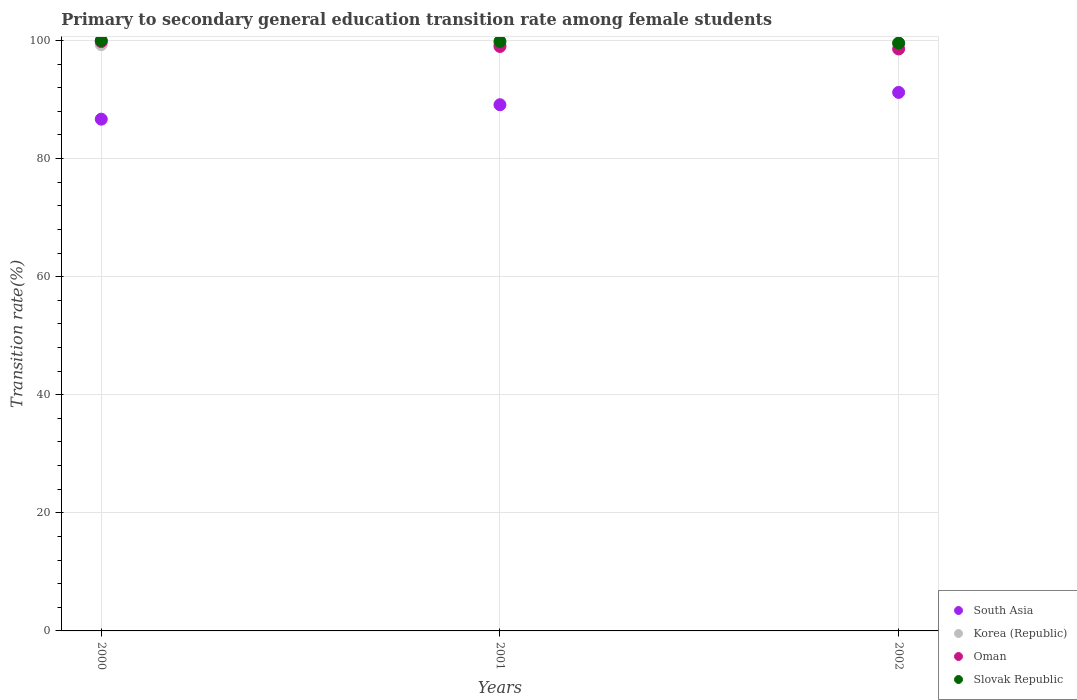How many different coloured dotlines are there?
Ensure brevity in your answer.  4. What is the transition rate in Slovak Republic in 2001?
Your answer should be compact. 99.84. Across all years, what is the maximum transition rate in Slovak Republic?
Your answer should be very brief. 100. Across all years, what is the minimum transition rate in Korea (Republic)?
Offer a very short reply. 99.28. In which year was the transition rate in South Asia maximum?
Provide a succinct answer. 2002. What is the total transition rate in Oman in the graph?
Give a very brief answer. 297.37. What is the difference between the transition rate in Korea (Republic) in 2000 and that in 2002?
Provide a short and direct response. -0.15. What is the difference between the transition rate in Korea (Republic) in 2001 and the transition rate in Slovak Republic in 2000?
Offer a very short reply. -0.72. What is the average transition rate in South Asia per year?
Offer a very short reply. 89. In the year 2000, what is the difference between the transition rate in Oman and transition rate in South Asia?
Your answer should be very brief. 13.14. What is the ratio of the transition rate in Oman in 2000 to that in 2002?
Offer a terse response. 1.01. What is the difference between the highest and the second highest transition rate in Korea (Republic)?
Provide a short and direct response. 0.15. What is the difference between the highest and the lowest transition rate in South Asia?
Keep it short and to the point. 4.53. In how many years, is the transition rate in Oman greater than the average transition rate in Oman taken over all years?
Offer a very short reply. 1. Is the transition rate in Slovak Republic strictly greater than the transition rate in South Asia over the years?
Give a very brief answer. Yes. Are the values on the major ticks of Y-axis written in scientific E-notation?
Give a very brief answer. No. Does the graph contain grids?
Your response must be concise. Yes. Where does the legend appear in the graph?
Make the answer very short. Bottom right. What is the title of the graph?
Your answer should be compact. Primary to secondary general education transition rate among female students. What is the label or title of the X-axis?
Your answer should be compact. Years. What is the label or title of the Y-axis?
Offer a very short reply. Transition rate(%). What is the Transition rate(%) of South Asia in 2000?
Provide a short and direct response. 86.68. What is the Transition rate(%) of Korea (Republic) in 2000?
Make the answer very short. 99.31. What is the Transition rate(%) of Oman in 2000?
Ensure brevity in your answer.  99.81. What is the Transition rate(%) in Slovak Republic in 2000?
Offer a very short reply. 100. What is the Transition rate(%) in South Asia in 2001?
Offer a very short reply. 89.12. What is the Transition rate(%) in Korea (Republic) in 2001?
Provide a short and direct response. 99.28. What is the Transition rate(%) of Oman in 2001?
Your answer should be very brief. 98.99. What is the Transition rate(%) in Slovak Republic in 2001?
Make the answer very short. 99.84. What is the Transition rate(%) in South Asia in 2002?
Offer a very short reply. 91.21. What is the Transition rate(%) in Korea (Republic) in 2002?
Give a very brief answer. 99.46. What is the Transition rate(%) in Oman in 2002?
Make the answer very short. 98.57. What is the Transition rate(%) of Slovak Republic in 2002?
Provide a succinct answer. 99.56. Across all years, what is the maximum Transition rate(%) of South Asia?
Your answer should be compact. 91.21. Across all years, what is the maximum Transition rate(%) of Korea (Republic)?
Offer a very short reply. 99.46. Across all years, what is the maximum Transition rate(%) of Oman?
Give a very brief answer. 99.81. Across all years, what is the minimum Transition rate(%) in South Asia?
Ensure brevity in your answer.  86.68. Across all years, what is the minimum Transition rate(%) of Korea (Republic)?
Provide a short and direct response. 99.28. Across all years, what is the minimum Transition rate(%) in Oman?
Offer a terse response. 98.57. Across all years, what is the minimum Transition rate(%) of Slovak Republic?
Keep it short and to the point. 99.56. What is the total Transition rate(%) in South Asia in the graph?
Give a very brief answer. 267.01. What is the total Transition rate(%) in Korea (Republic) in the graph?
Ensure brevity in your answer.  298.05. What is the total Transition rate(%) of Oman in the graph?
Your answer should be compact. 297.37. What is the total Transition rate(%) in Slovak Republic in the graph?
Your answer should be very brief. 299.41. What is the difference between the Transition rate(%) of South Asia in 2000 and that in 2001?
Give a very brief answer. -2.44. What is the difference between the Transition rate(%) of Korea (Republic) in 2000 and that in 2001?
Provide a succinct answer. 0.03. What is the difference between the Transition rate(%) of Oman in 2000 and that in 2001?
Offer a terse response. 0.82. What is the difference between the Transition rate(%) in Slovak Republic in 2000 and that in 2001?
Make the answer very short. 0.16. What is the difference between the Transition rate(%) of South Asia in 2000 and that in 2002?
Provide a succinct answer. -4.53. What is the difference between the Transition rate(%) of Korea (Republic) in 2000 and that in 2002?
Your answer should be very brief. -0.15. What is the difference between the Transition rate(%) of Oman in 2000 and that in 2002?
Your answer should be compact. 1.25. What is the difference between the Transition rate(%) of Slovak Republic in 2000 and that in 2002?
Your response must be concise. 0.44. What is the difference between the Transition rate(%) in South Asia in 2001 and that in 2002?
Your answer should be very brief. -2.09. What is the difference between the Transition rate(%) in Korea (Republic) in 2001 and that in 2002?
Offer a very short reply. -0.17. What is the difference between the Transition rate(%) of Oman in 2001 and that in 2002?
Provide a succinct answer. 0.42. What is the difference between the Transition rate(%) in Slovak Republic in 2001 and that in 2002?
Provide a short and direct response. 0.28. What is the difference between the Transition rate(%) in South Asia in 2000 and the Transition rate(%) in Korea (Republic) in 2001?
Offer a very short reply. -12.61. What is the difference between the Transition rate(%) of South Asia in 2000 and the Transition rate(%) of Oman in 2001?
Provide a short and direct response. -12.31. What is the difference between the Transition rate(%) in South Asia in 2000 and the Transition rate(%) in Slovak Republic in 2001?
Give a very brief answer. -13.17. What is the difference between the Transition rate(%) in Korea (Republic) in 2000 and the Transition rate(%) in Oman in 2001?
Provide a short and direct response. 0.32. What is the difference between the Transition rate(%) in Korea (Republic) in 2000 and the Transition rate(%) in Slovak Republic in 2001?
Offer a terse response. -0.54. What is the difference between the Transition rate(%) in Oman in 2000 and the Transition rate(%) in Slovak Republic in 2001?
Your answer should be compact. -0.03. What is the difference between the Transition rate(%) in South Asia in 2000 and the Transition rate(%) in Korea (Republic) in 2002?
Offer a terse response. -12.78. What is the difference between the Transition rate(%) in South Asia in 2000 and the Transition rate(%) in Oman in 2002?
Provide a succinct answer. -11.89. What is the difference between the Transition rate(%) in South Asia in 2000 and the Transition rate(%) in Slovak Republic in 2002?
Give a very brief answer. -12.89. What is the difference between the Transition rate(%) of Korea (Republic) in 2000 and the Transition rate(%) of Oman in 2002?
Keep it short and to the point. 0.74. What is the difference between the Transition rate(%) in Korea (Republic) in 2000 and the Transition rate(%) in Slovak Republic in 2002?
Ensure brevity in your answer.  -0.25. What is the difference between the Transition rate(%) of Oman in 2000 and the Transition rate(%) of Slovak Republic in 2002?
Your answer should be compact. 0.25. What is the difference between the Transition rate(%) in South Asia in 2001 and the Transition rate(%) in Korea (Republic) in 2002?
Provide a succinct answer. -10.34. What is the difference between the Transition rate(%) of South Asia in 2001 and the Transition rate(%) of Oman in 2002?
Ensure brevity in your answer.  -9.45. What is the difference between the Transition rate(%) of South Asia in 2001 and the Transition rate(%) of Slovak Republic in 2002?
Make the answer very short. -10.44. What is the difference between the Transition rate(%) in Korea (Republic) in 2001 and the Transition rate(%) in Oman in 2002?
Offer a terse response. 0.72. What is the difference between the Transition rate(%) of Korea (Republic) in 2001 and the Transition rate(%) of Slovak Republic in 2002?
Provide a succinct answer. -0.28. What is the difference between the Transition rate(%) in Oman in 2001 and the Transition rate(%) in Slovak Republic in 2002?
Give a very brief answer. -0.57. What is the average Transition rate(%) in South Asia per year?
Keep it short and to the point. 89. What is the average Transition rate(%) of Korea (Republic) per year?
Keep it short and to the point. 99.35. What is the average Transition rate(%) of Oman per year?
Offer a very short reply. 99.12. What is the average Transition rate(%) of Slovak Republic per year?
Keep it short and to the point. 99.8. In the year 2000, what is the difference between the Transition rate(%) of South Asia and Transition rate(%) of Korea (Republic)?
Your answer should be very brief. -12.63. In the year 2000, what is the difference between the Transition rate(%) in South Asia and Transition rate(%) in Oman?
Make the answer very short. -13.14. In the year 2000, what is the difference between the Transition rate(%) in South Asia and Transition rate(%) in Slovak Republic?
Provide a succinct answer. -13.32. In the year 2000, what is the difference between the Transition rate(%) in Korea (Republic) and Transition rate(%) in Oman?
Make the answer very short. -0.5. In the year 2000, what is the difference between the Transition rate(%) of Korea (Republic) and Transition rate(%) of Slovak Republic?
Make the answer very short. -0.69. In the year 2000, what is the difference between the Transition rate(%) of Oman and Transition rate(%) of Slovak Republic?
Your answer should be very brief. -0.19. In the year 2001, what is the difference between the Transition rate(%) of South Asia and Transition rate(%) of Korea (Republic)?
Keep it short and to the point. -10.16. In the year 2001, what is the difference between the Transition rate(%) of South Asia and Transition rate(%) of Oman?
Keep it short and to the point. -9.87. In the year 2001, what is the difference between the Transition rate(%) in South Asia and Transition rate(%) in Slovak Republic?
Your answer should be compact. -10.72. In the year 2001, what is the difference between the Transition rate(%) of Korea (Republic) and Transition rate(%) of Oman?
Your answer should be very brief. 0.29. In the year 2001, what is the difference between the Transition rate(%) in Korea (Republic) and Transition rate(%) in Slovak Republic?
Offer a very short reply. -0.56. In the year 2001, what is the difference between the Transition rate(%) of Oman and Transition rate(%) of Slovak Republic?
Provide a short and direct response. -0.85. In the year 2002, what is the difference between the Transition rate(%) in South Asia and Transition rate(%) in Korea (Republic)?
Make the answer very short. -8.25. In the year 2002, what is the difference between the Transition rate(%) of South Asia and Transition rate(%) of Oman?
Keep it short and to the point. -7.36. In the year 2002, what is the difference between the Transition rate(%) of South Asia and Transition rate(%) of Slovak Republic?
Make the answer very short. -8.35. In the year 2002, what is the difference between the Transition rate(%) in Korea (Republic) and Transition rate(%) in Oman?
Your response must be concise. 0.89. In the year 2002, what is the difference between the Transition rate(%) in Korea (Republic) and Transition rate(%) in Slovak Republic?
Provide a short and direct response. -0.11. In the year 2002, what is the difference between the Transition rate(%) of Oman and Transition rate(%) of Slovak Republic?
Your answer should be very brief. -1. What is the ratio of the Transition rate(%) of South Asia in 2000 to that in 2001?
Make the answer very short. 0.97. What is the ratio of the Transition rate(%) of Korea (Republic) in 2000 to that in 2001?
Make the answer very short. 1. What is the ratio of the Transition rate(%) in Oman in 2000 to that in 2001?
Make the answer very short. 1.01. What is the ratio of the Transition rate(%) of South Asia in 2000 to that in 2002?
Offer a very short reply. 0.95. What is the ratio of the Transition rate(%) in Oman in 2000 to that in 2002?
Provide a succinct answer. 1.01. What is the ratio of the Transition rate(%) in Slovak Republic in 2000 to that in 2002?
Offer a very short reply. 1. What is the ratio of the Transition rate(%) in South Asia in 2001 to that in 2002?
Provide a succinct answer. 0.98. What is the ratio of the Transition rate(%) of Korea (Republic) in 2001 to that in 2002?
Ensure brevity in your answer.  1. What is the difference between the highest and the second highest Transition rate(%) of South Asia?
Offer a terse response. 2.09. What is the difference between the highest and the second highest Transition rate(%) in Korea (Republic)?
Offer a terse response. 0.15. What is the difference between the highest and the second highest Transition rate(%) of Oman?
Your response must be concise. 0.82. What is the difference between the highest and the second highest Transition rate(%) of Slovak Republic?
Keep it short and to the point. 0.16. What is the difference between the highest and the lowest Transition rate(%) of South Asia?
Your answer should be very brief. 4.53. What is the difference between the highest and the lowest Transition rate(%) in Korea (Republic)?
Offer a terse response. 0.17. What is the difference between the highest and the lowest Transition rate(%) of Oman?
Offer a very short reply. 1.25. What is the difference between the highest and the lowest Transition rate(%) in Slovak Republic?
Your answer should be compact. 0.44. 